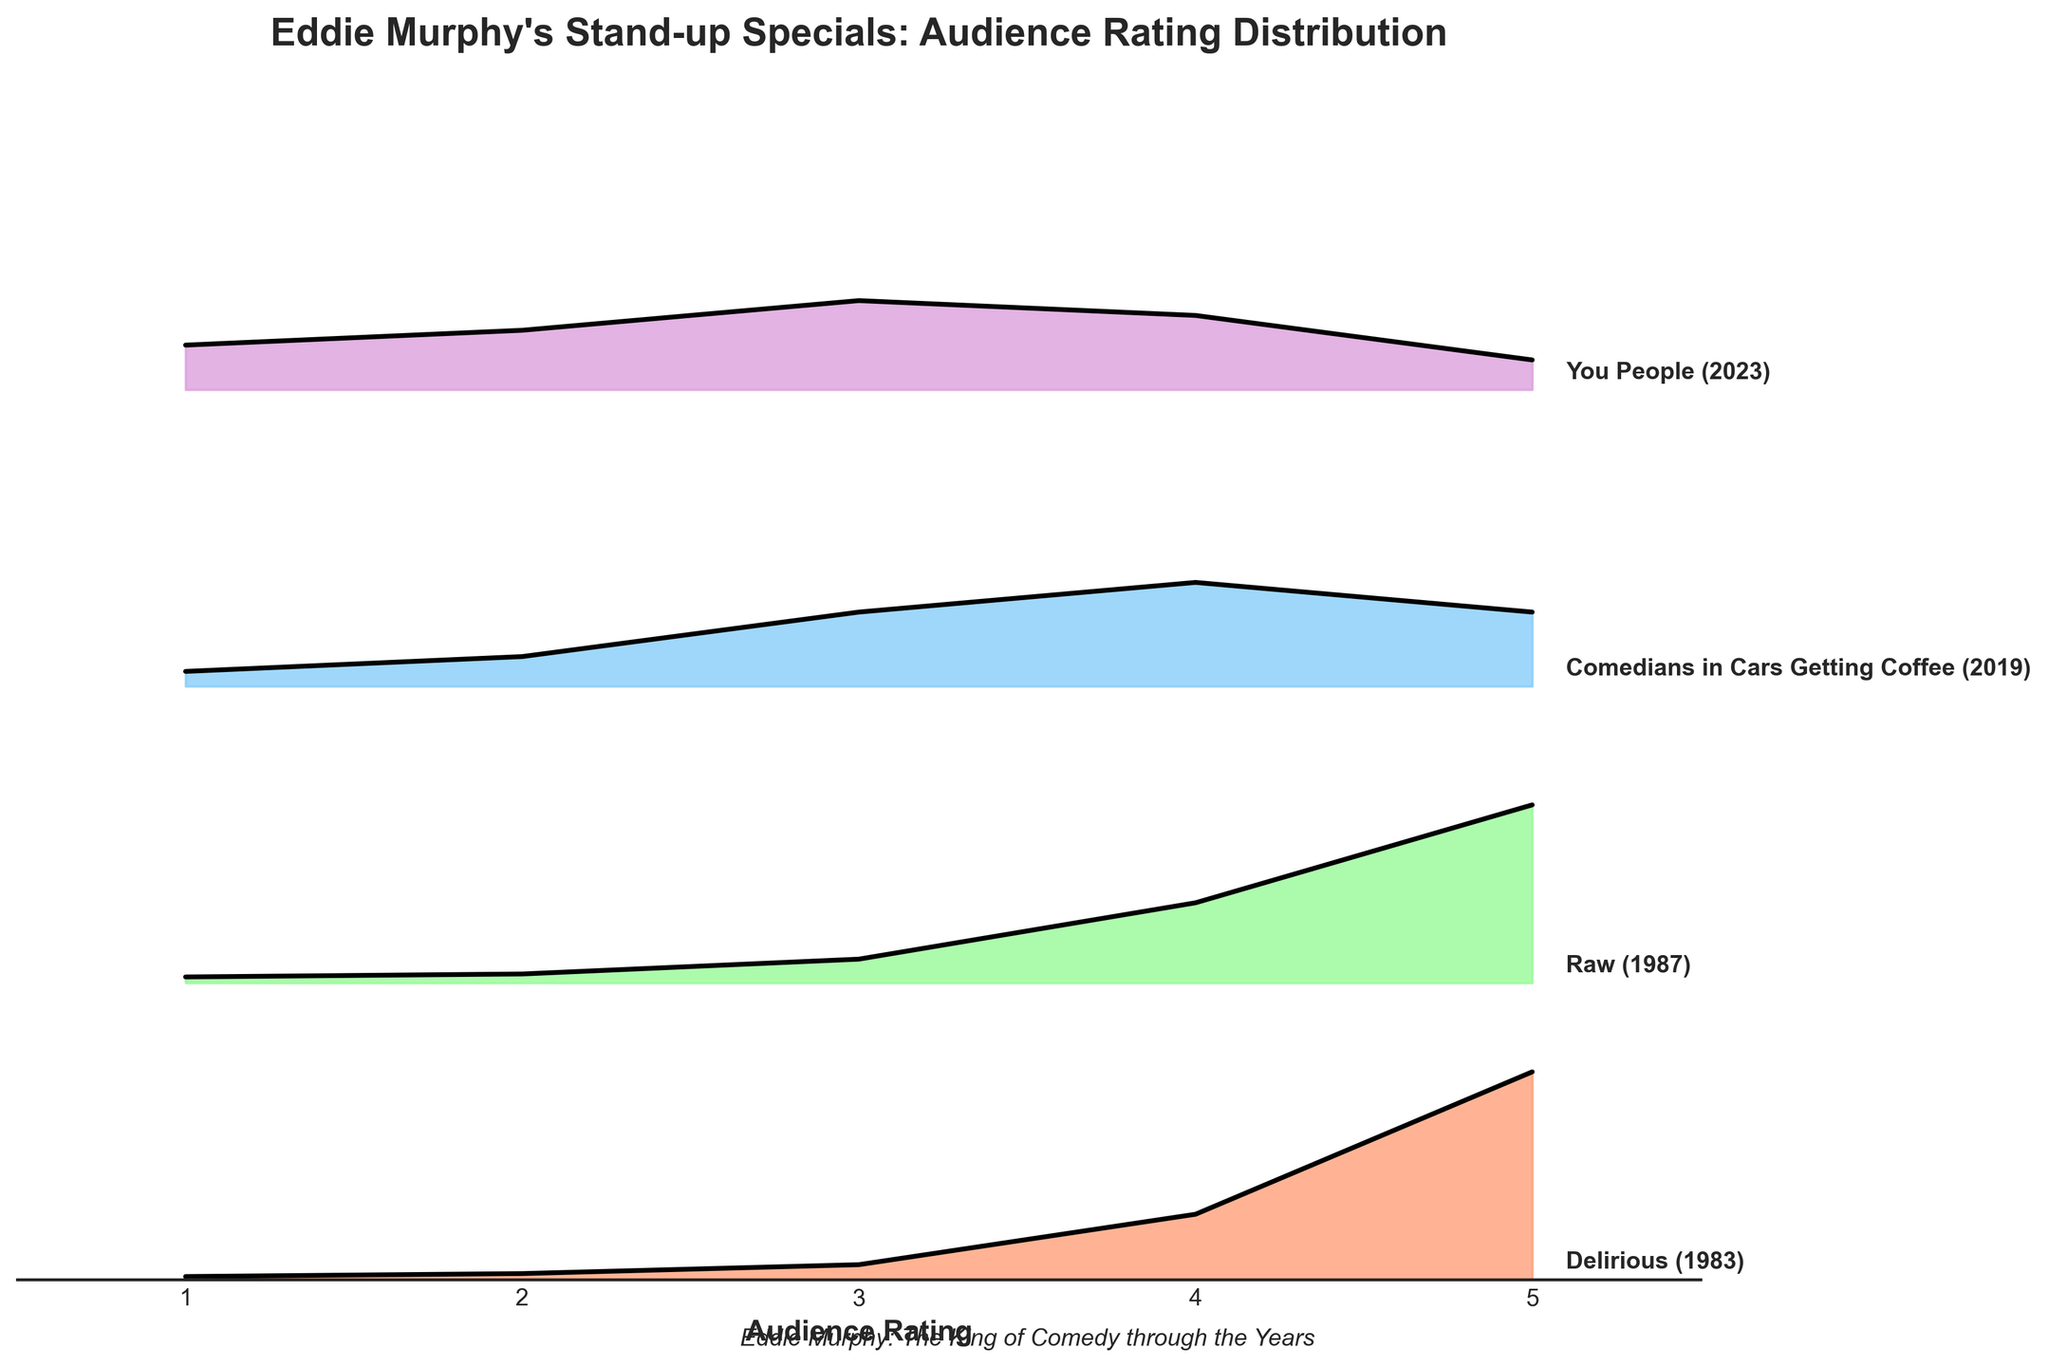What is the title of the figure? The title is typically located at the top of the chart, usually in a larger and bolder font compared to other text.
Answer: "Eddie Murphy's Stand-up Specials: Audience Rating Distribution" What is the range of audience ratings displayed on the x-axis? The x-axis represents the audience ratings, typically shown as a horizontal line with labels indicating the range of values. From the figure, we can see the minimum rating is 1 and the maximum rating is 5.
Answer: 1 to 5 Which Eddie Murphy special has the highest distribution peak at a rating of 5? To determine which special has the highest distribution at a rating of 5, we compare the peaks at the rating of 5 across all the specials shown in the ridgeline plot. "Delirious" and "Raw" both have significant peaks, but "Delirious" reaches the highest distribution value.
Answer: Delirious In which year was the special "Raw" released? The year of release for each special is labeled next to the special name in the plot. By looking at "Raw," we can see it is annotated with the year "1987."
Answer: 1987 What is the audience rating that has the highest distribution for the special "You People"? To find the highest distribution for "You People," locate the ridgeline corresponding to "You People" and identify the rating with the highest peak on this line. The highest peak occurs at a rating of 3.
Answer: 3 Which special has the lowest distribution at the rating of 1? By examining the ridgelines at the rating of 1, we can see that "Delirious" has the lowest distribution value for this rating compared to other specials.
Answer: Delirious Comparing "Comedians in Cars Getting Coffee" and "You People," which special has a more evenly distributed audience rating? To determine which special has a more even distribution, compare the shapes of their ridgelines. "Comedians in Cars Getting Coffee" has a more spread-out distribution across different ratings compared to "You People," which shows a more concentrated peak distribution.
Answer: Comedians in Cars Getting Coffee Which special has an audience rating distribution that leans the most towards higher ratings (4 and 5)? By inspecting the ridgelines and focusing on the distribution values at ratings 4 and 5, "Raw" shows the highest combined distribution leaning towards these higher ratings.
Answer: Raw What does the special "Raw" have in common with "Delirious" in terms of their audience rating distributions? By examining the ridgelines for both "Raw" and "Delirious," we notice that both have prominent peaks at rating 5, indicating a high audience appreciation. Additionally, both have relatively higher distributions at the higher end of the rating scale.
Answer: High peaks at rating 5 